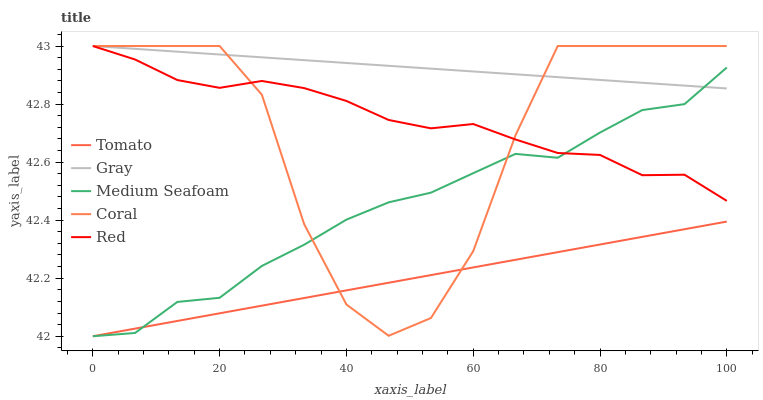Does Tomato have the minimum area under the curve?
Answer yes or no. Yes. Does Gray have the maximum area under the curve?
Answer yes or no. Yes. Does Coral have the minimum area under the curve?
Answer yes or no. No. Does Coral have the maximum area under the curve?
Answer yes or no. No. Is Gray the smoothest?
Answer yes or no. Yes. Is Coral the roughest?
Answer yes or no. Yes. Is Coral the smoothest?
Answer yes or no. No. Is Gray the roughest?
Answer yes or no. No. Does Tomato have the lowest value?
Answer yes or no. Yes. Does Coral have the lowest value?
Answer yes or no. No. Does Red have the highest value?
Answer yes or no. Yes. Does Medium Seafoam have the highest value?
Answer yes or no. No. Is Tomato less than Red?
Answer yes or no. Yes. Is Gray greater than Tomato?
Answer yes or no. Yes. Does Medium Seafoam intersect Tomato?
Answer yes or no. Yes. Is Medium Seafoam less than Tomato?
Answer yes or no. No. Is Medium Seafoam greater than Tomato?
Answer yes or no. No. Does Tomato intersect Red?
Answer yes or no. No. 